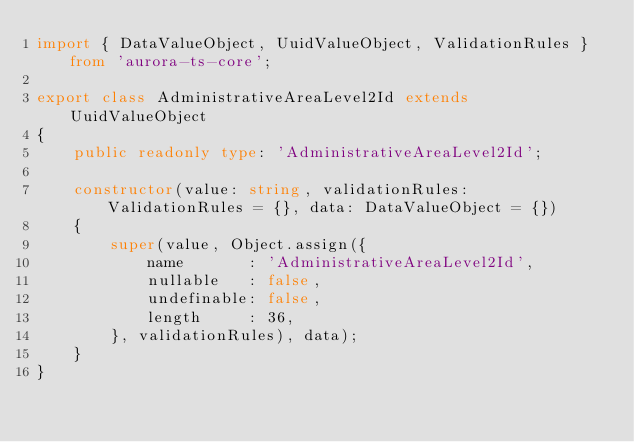<code> <loc_0><loc_0><loc_500><loc_500><_TypeScript_>import { DataValueObject, UuidValueObject, ValidationRules } from 'aurora-ts-core';

export class AdministrativeAreaLevel2Id extends UuidValueObject
{
    public readonly type: 'AdministrativeAreaLevel2Id';

    constructor(value: string, validationRules: ValidationRules = {}, data: DataValueObject = {})
    {
        super(value, Object.assign({
            name       : 'AdministrativeAreaLevel2Id',
            nullable   : false,
            undefinable: false,
            length     : 36,
        }, validationRules), data);
    }
}</code> 